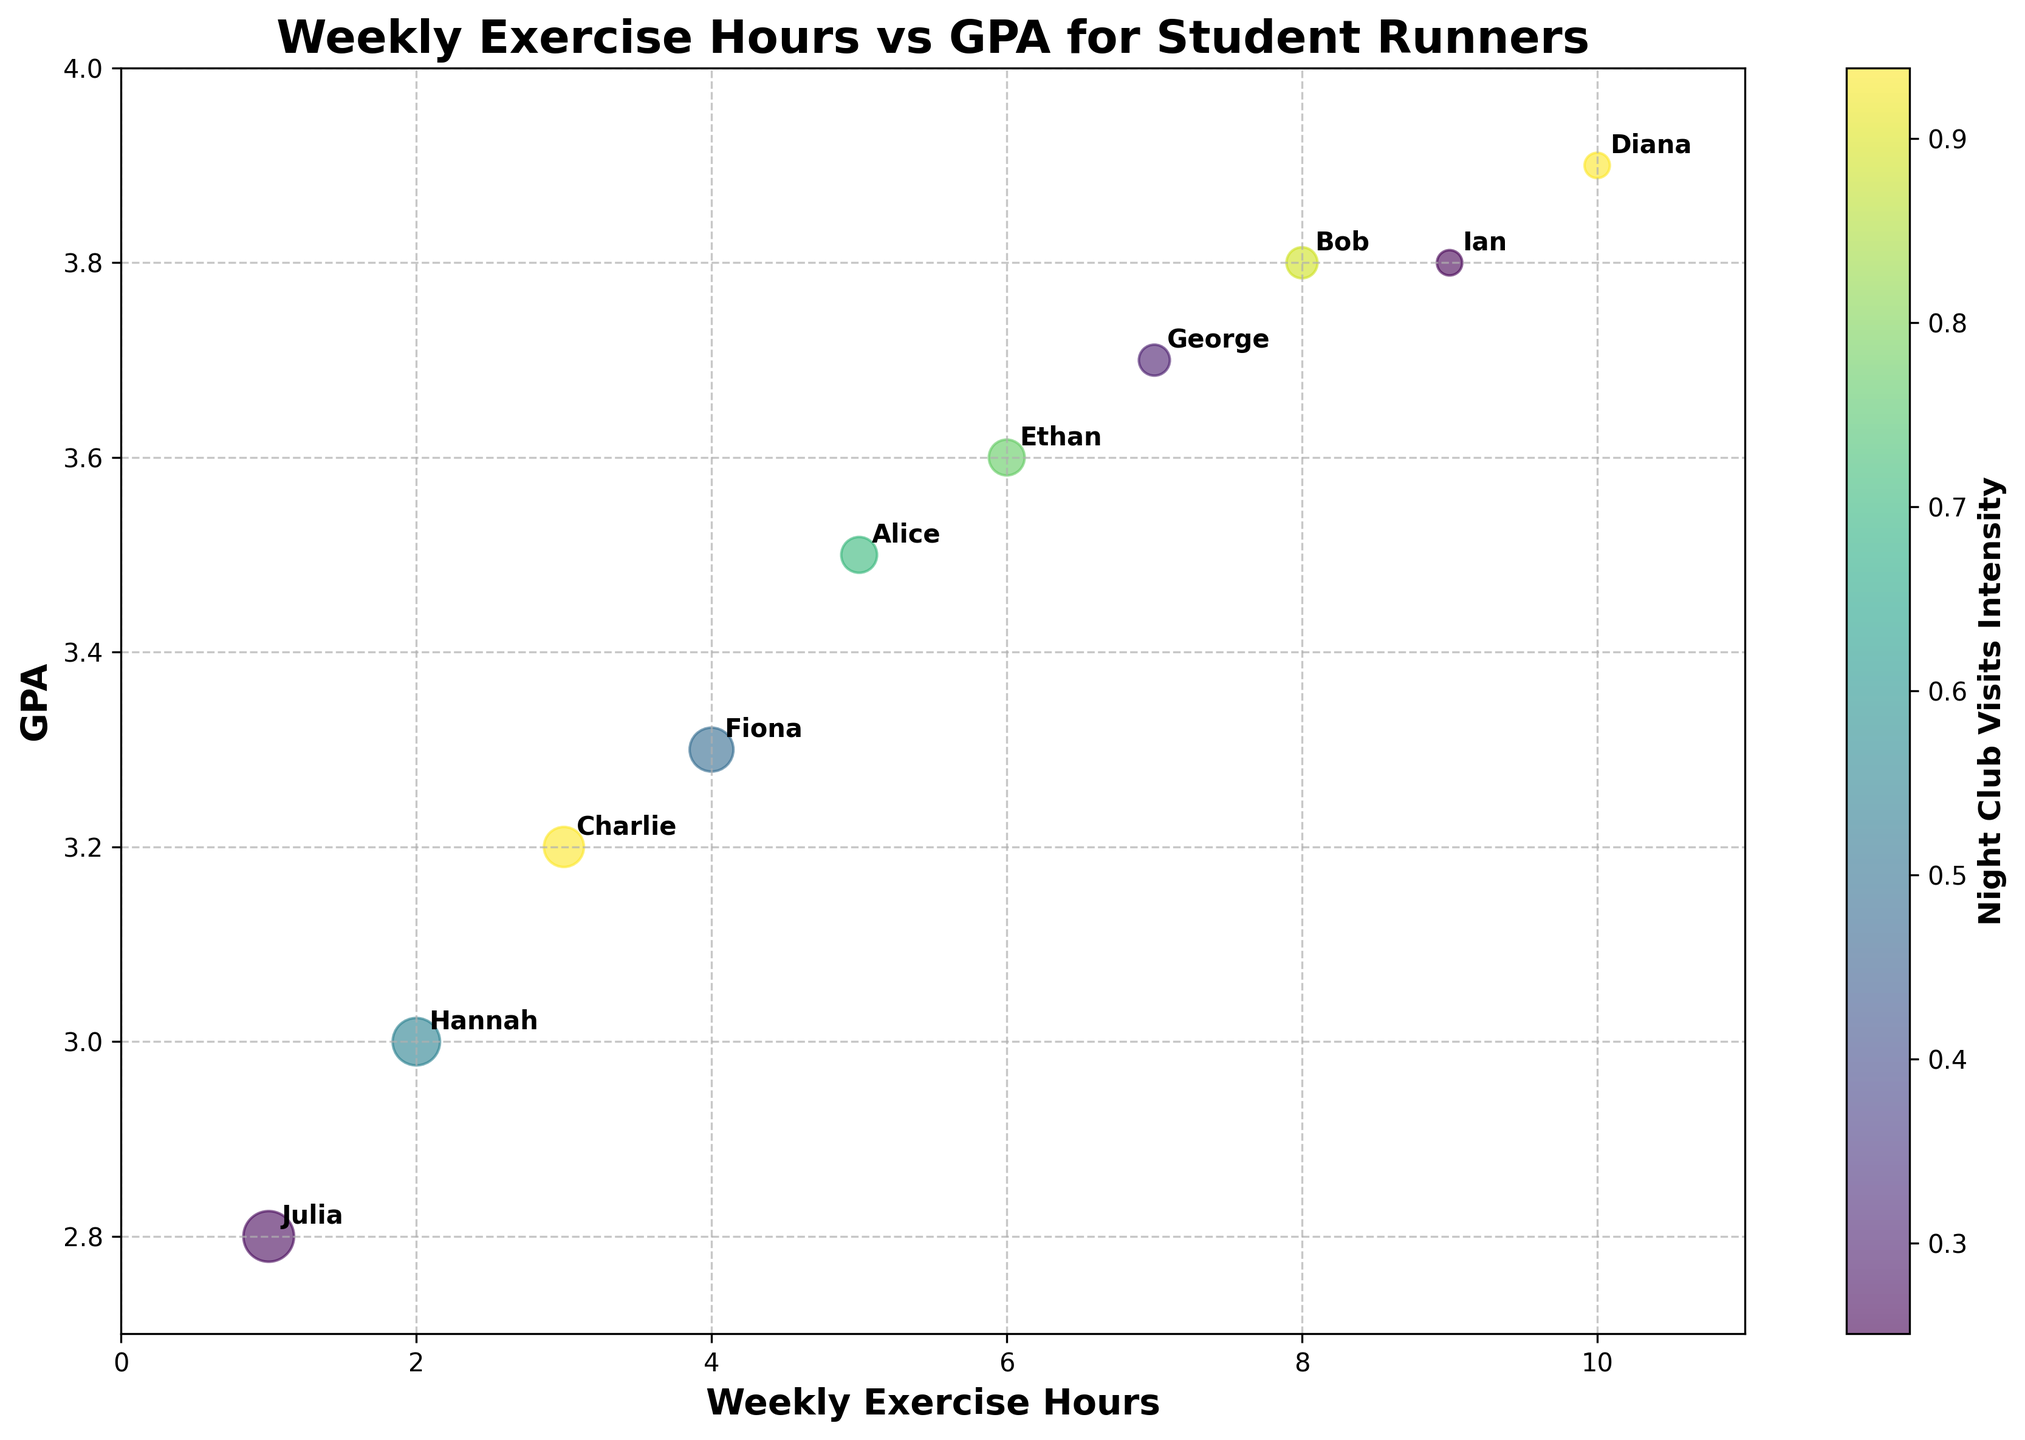Which student has the highest GPA? Looking at the vertical axis labeled "GPA," the student with the highest GPA of 3.9 is Diana.
Answer: Diana What is the title of the chart? The title is located at the top of the chart and it reads "Weekly Exercise Hours vs GPA for Student Runners."
Answer: Weekly Exercise Hours vs GPA for Student Runners How many weekly exercise hours does the student with the lowest GPA have? Julia has the lowest GPA of 2.8. Looking at the corresponding point on the horizontal axis, she exercises for 1 hour per week.
Answer: 1 hour Which student has zero night club visits and how does it correlate with their GPA? Both Diana and Ian have zero night club visits. Their GPAs are 3.9 and 3.8 respectively. This suggests a possible positive correlation between fewer night club visits and higher GPA.
Answer: Diana and Ian; correlated with higher GPA Compare the number of weekly exercise hours between Alice and Ethan. Who exercises more? Referring to the horizontal axis labeled "Weekly Exercise Hours," Alice exercises for 5 hours a week while Ethan exercises for 6 hours a week. Ethan exercises more.
Answer: Ethan Which student visits night clubs most frequently, and what is their GPA? Julia visits night clubs most frequently with 6 visits, indicated by the largest bubble size. Her GPA is 2.8, one of the lowest among the group.
Answer: Julia; GPA is 2.8 What is the range of weekly exercise hours among the students? The minimum weekly exercise hours is 1 (Julia) and the maximum is 10 (Diana), so the range is 10 - 1 = 9 hours.
Answer: 9 hours Identify the student with the highest number of night club visits and the student with the highest GPA. Do they overlap? Julia has the highest number of night club visits (6), and Diana has the highest GPA (3.9). These are not the same individuals.
Answer: No, they do not overlap What is the average GPA of students who exercise 8 or more hours per week? Bob (8 hours, 3.8 GPA), Diana (10 hours, 3.9 GPA), and Ian (9 hours, 3.8 GPA) exercise 8 or more hours. Their average GPA is (3.8 + 3.9 + 3.8) / 3 = 3.83.
Answer: 3.83 Among students who visit night clubs exactly twice a week, who has the higher GPA? Alice and Ethan visit night clubs twice. Alice has a GPA of 3.5, and Ethan has a GPA of 3.6. Therefore, Ethan has the higher GPA.
Answer: Ethan 